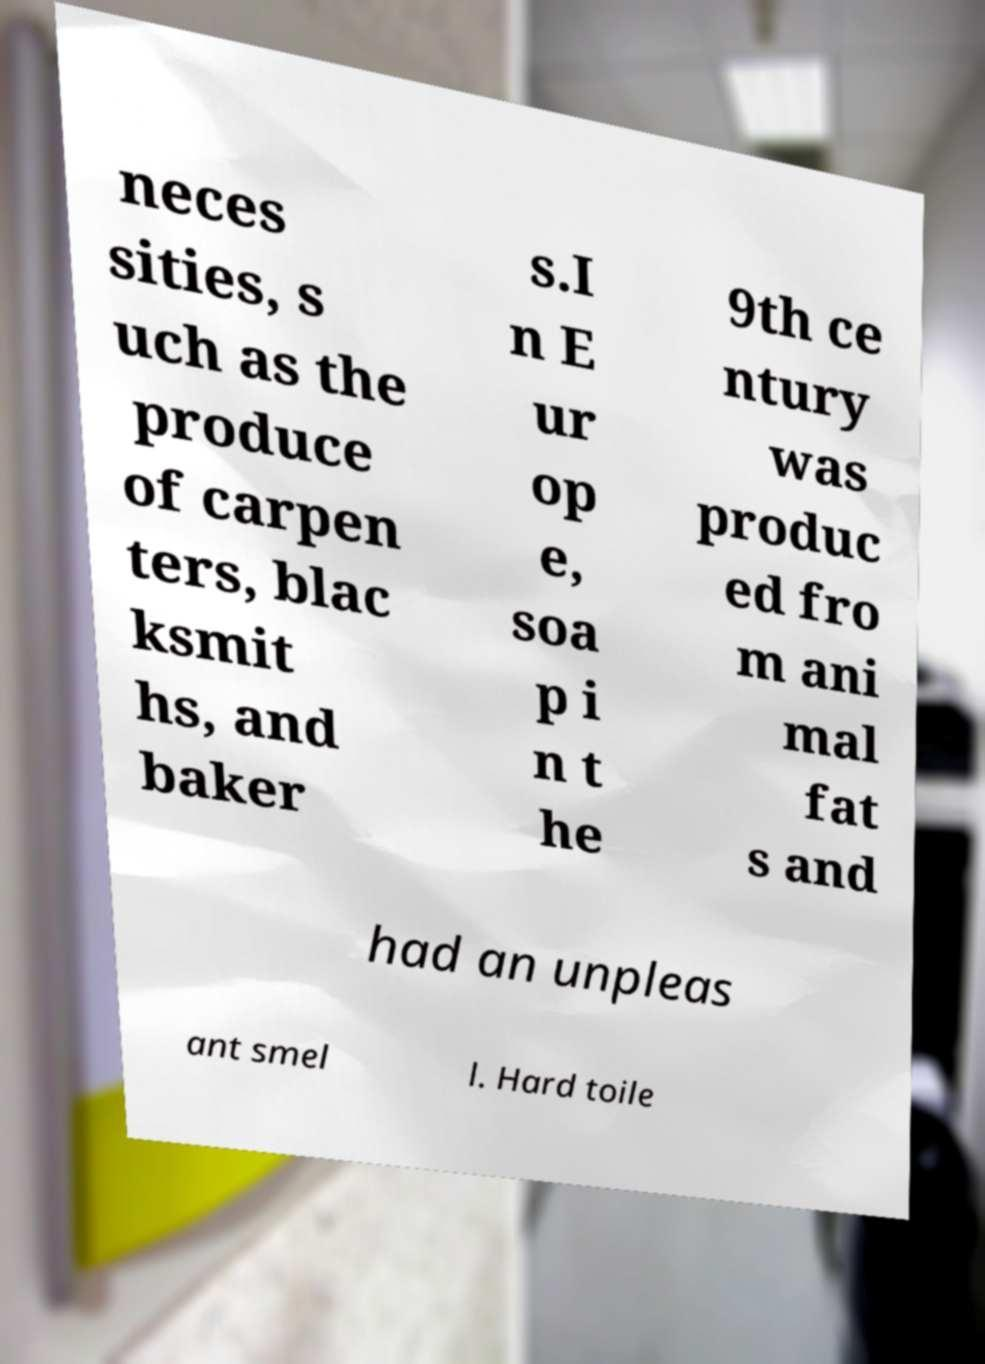I need the written content from this picture converted into text. Can you do that? neces sities, s uch as the produce of carpen ters, blac ksmit hs, and baker s.I n E ur op e, soa p i n t he 9th ce ntury was produc ed fro m ani mal fat s and had an unpleas ant smel l. Hard toile 